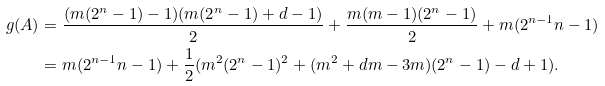<formula> <loc_0><loc_0><loc_500><loc_500>g ( A ) & = \frac { ( m ( 2 ^ { n } - 1 ) - 1 ) ( m ( 2 ^ { n } - 1 ) + d - 1 ) } { 2 } + \frac { m ( m - 1 ) ( 2 ^ { n } - 1 ) } { 2 } + m ( 2 ^ { n - 1 } n - 1 ) \\ & = m ( 2 ^ { n - 1 } n - 1 ) + \frac { 1 } { 2 } ( m ^ { 2 } ( 2 ^ { n } - 1 ) ^ { 2 } + ( m ^ { 2 } + d m - 3 m ) ( 2 ^ { n } - 1 ) - d + 1 ) .</formula> 